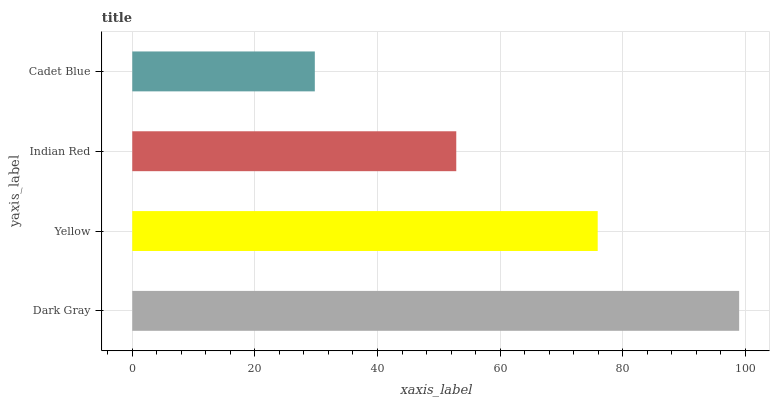Is Cadet Blue the minimum?
Answer yes or no. Yes. Is Dark Gray the maximum?
Answer yes or no. Yes. Is Yellow the minimum?
Answer yes or no. No. Is Yellow the maximum?
Answer yes or no. No. Is Dark Gray greater than Yellow?
Answer yes or no. Yes. Is Yellow less than Dark Gray?
Answer yes or no. Yes. Is Yellow greater than Dark Gray?
Answer yes or no. No. Is Dark Gray less than Yellow?
Answer yes or no. No. Is Yellow the high median?
Answer yes or no. Yes. Is Indian Red the low median?
Answer yes or no. Yes. Is Cadet Blue the high median?
Answer yes or no. No. Is Yellow the low median?
Answer yes or no. No. 